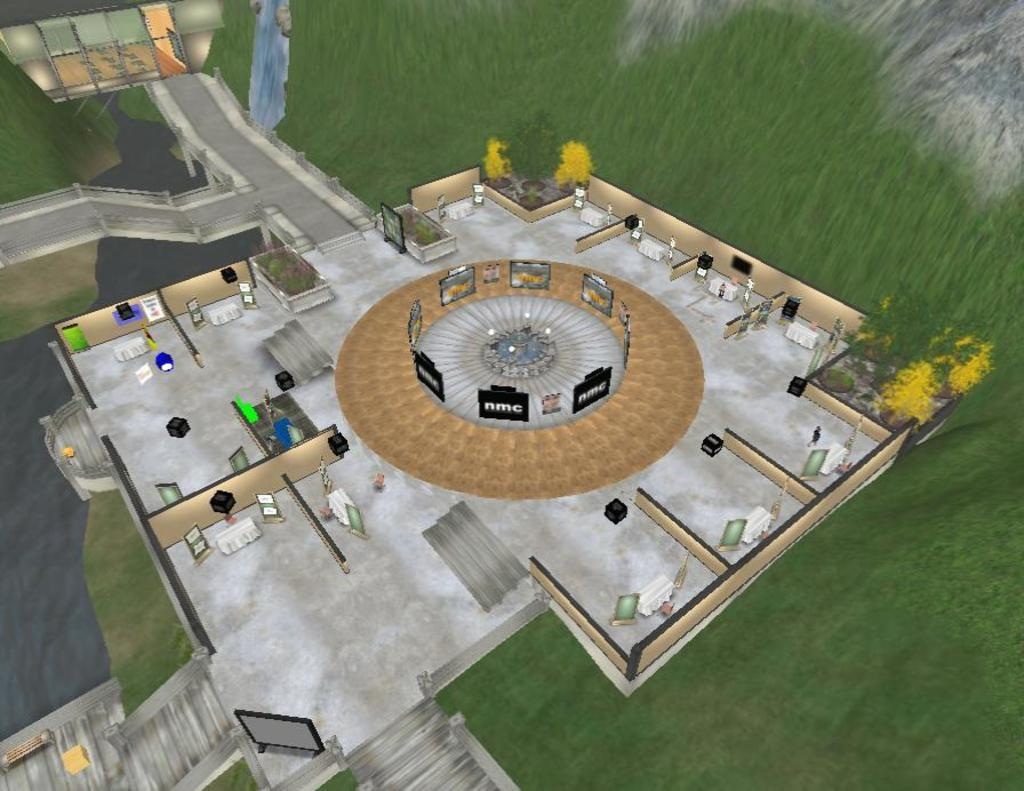What type of image is being described? The image is graphical in nature. What can be found in the center of the image? There is grass, a hill, a building, and a few other objects in the center of the image. How does the knife contribute to the image's theme of death? There is no knife present in the image, and the theme of death is not mentioned in the provided facts. 